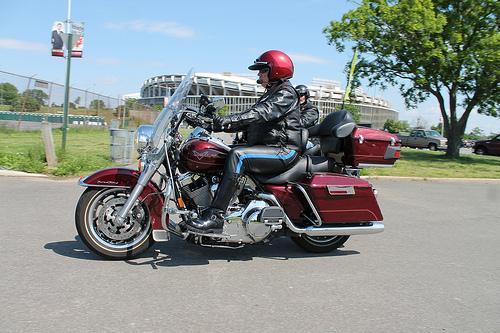How many motorbikes are on the road?
Give a very brief answer. 2. 